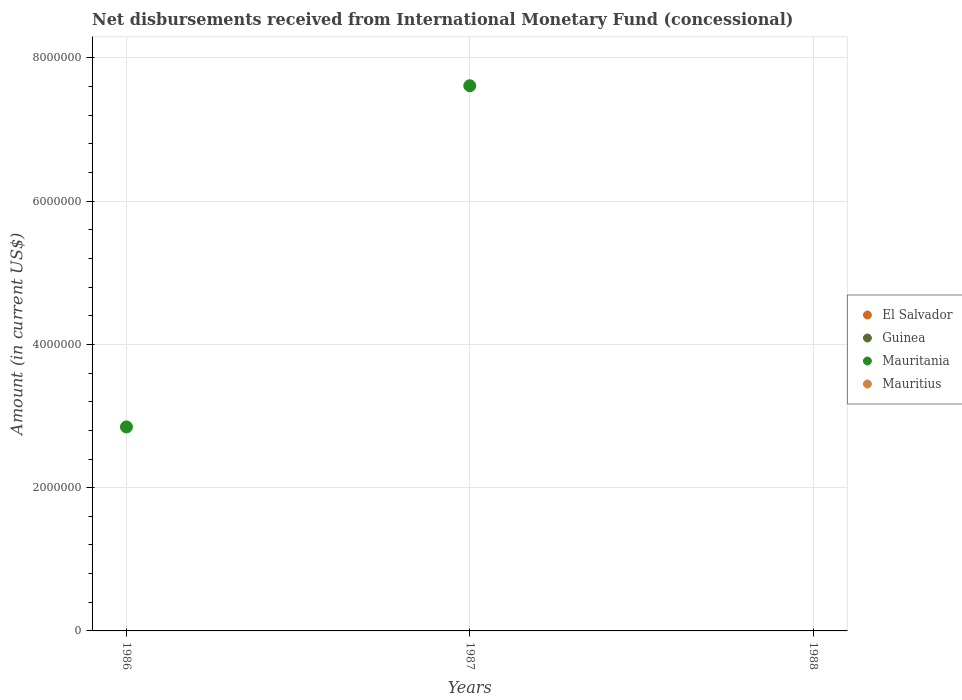What is the amount of disbursements received from International Monetary Fund in Mauritania in 1988?
Your response must be concise. 0. Across all years, what is the maximum amount of disbursements received from International Monetary Fund in Mauritania?
Provide a short and direct response. 7.61e+06. Across all years, what is the minimum amount of disbursements received from International Monetary Fund in Guinea?
Ensure brevity in your answer.  0. What is the total amount of disbursements received from International Monetary Fund in Guinea in the graph?
Offer a very short reply. 0. What is the average amount of disbursements received from International Monetary Fund in Mauritius per year?
Give a very brief answer. 0. What is the ratio of the amount of disbursements received from International Monetary Fund in Mauritania in 1986 to that in 1987?
Your answer should be compact. 0.37. What is the difference between the highest and the lowest amount of disbursements received from International Monetary Fund in Mauritania?
Give a very brief answer. 7.61e+06. In how many years, is the amount of disbursements received from International Monetary Fund in Mauritius greater than the average amount of disbursements received from International Monetary Fund in Mauritius taken over all years?
Give a very brief answer. 0. Is it the case that in every year, the sum of the amount of disbursements received from International Monetary Fund in Mauritania and amount of disbursements received from International Monetary Fund in Mauritius  is greater than the sum of amount of disbursements received from International Monetary Fund in El Salvador and amount of disbursements received from International Monetary Fund in Guinea?
Provide a succinct answer. No. Is it the case that in every year, the sum of the amount of disbursements received from International Monetary Fund in Guinea and amount of disbursements received from International Monetary Fund in Mauritania  is greater than the amount of disbursements received from International Monetary Fund in Mauritius?
Your answer should be compact. No. Is the amount of disbursements received from International Monetary Fund in Mauritius strictly less than the amount of disbursements received from International Monetary Fund in Mauritania over the years?
Make the answer very short. No. What is the difference between two consecutive major ticks on the Y-axis?
Your response must be concise. 2.00e+06. Does the graph contain any zero values?
Your response must be concise. Yes. How are the legend labels stacked?
Your response must be concise. Vertical. What is the title of the graph?
Provide a short and direct response. Net disbursements received from International Monetary Fund (concessional). Does "Zambia" appear as one of the legend labels in the graph?
Give a very brief answer. No. What is the Amount (in current US$) of El Salvador in 1986?
Offer a very short reply. 0. What is the Amount (in current US$) in Guinea in 1986?
Make the answer very short. 0. What is the Amount (in current US$) of Mauritania in 1986?
Ensure brevity in your answer.  2.85e+06. What is the Amount (in current US$) in El Salvador in 1987?
Make the answer very short. 0. What is the Amount (in current US$) of Mauritania in 1987?
Provide a succinct answer. 7.61e+06. What is the Amount (in current US$) in Mauritius in 1987?
Offer a very short reply. 0. What is the Amount (in current US$) of Guinea in 1988?
Offer a terse response. 0. What is the Amount (in current US$) in Mauritania in 1988?
Provide a succinct answer. 0. What is the Amount (in current US$) in Mauritius in 1988?
Your answer should be compact. 0. Across all years, what is the maximum Amount (in current US$) of Mauritania?
Provide a short and direct response. 7.61e+06. Across all years, what is the minimum Amount (in current US$) of Mauritania?
Ensure brevity in your answer.  0. What is the total Amount (in current US$) in Guinea in the graph?
Your answer should be very brief. 0. What is the total Amount (in current US$) of Mauritania in the graph?
Provide a succinct answer. 1.05e+07. What is the total Amount (in current US$) of Mauritius in the graph?
Your answer should be very brief. 0. What is the difference between the Amount (in current US$) in Mauritania in 1986 and that in 1987?
Your answer should be very brief. -4.76e+06. What is the average Amount (in current US$) of Guinea per year?
Offer a very short reply. 0. What is the average Amount (in current US$) of Mauritania per year?
Keep it short and to the point. 3.49e+06. What is the average Amount (in current US$) in Mauritius per year?
Keep it short and to the point. 0. What is the ratio of the Amount (in current US$) in Mauritania in 1986 to that in 1987?
Your answer should be very brief. 0.37. What is the difference between the highest and the lowest Amount (in current US$) of Mauritania?
Provide a short and direct response. 7.61e+06. 